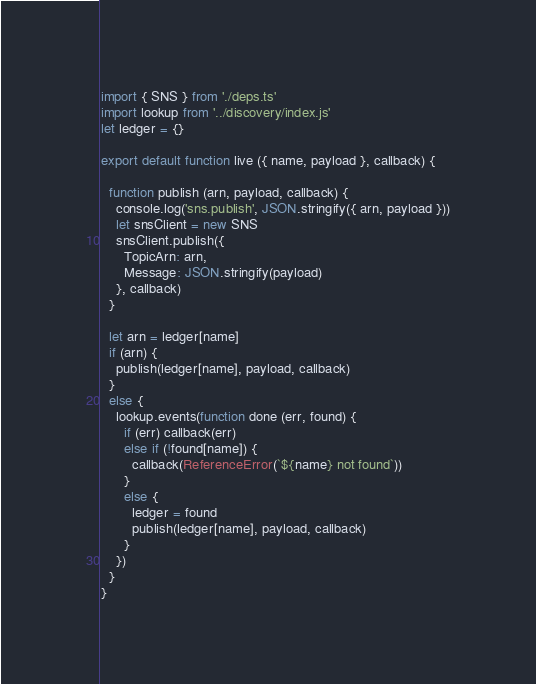<code> <loc_0><loc_0><loc_500><loc_500><_JavaScript_>import { SNS } from './deps.ts'
import lookup from '../discovery/index.js'
let ledger = {}

export default function live ({ name, payload }, callback) {

  function publish (arn, payload, callback) {
    console.log('sns.publish', JSON.stringify({ arn, payload }))
    let snsClient = new SNS
    snsClient.publish({
      TopicArn: arn,
      Message: JSON.stringify(payload)
    }, callback)
  }

  let arn = ledger[name]
  if (arn) {
    publish(ledger[name], payload, callback)
  }
  else {
    lookup.events(function done (err, found) {
      if (err) callback(err)
      else if (!found[name]) {
        callback(ReferenceError(`${name} not found`))
      }
      else {
        ledger = found
        publish(ledger[name], payload, callback)
      }
    })
  }
}
</code> 